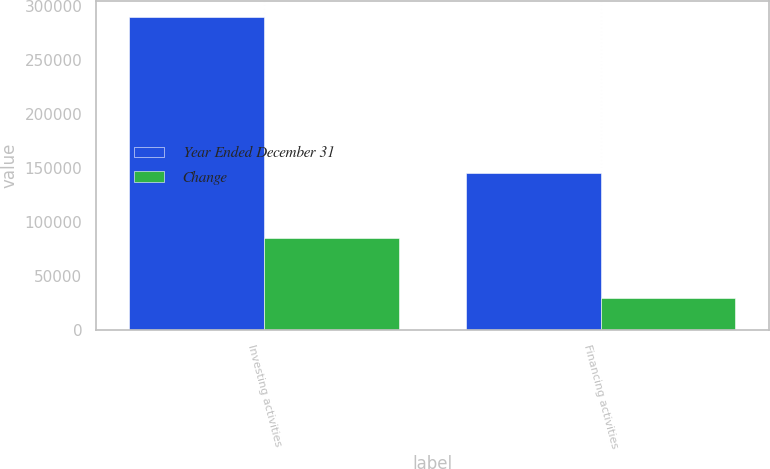Convert chart. <chart><loc_0><loc_0><loc_500><loc_500><stacked_bar_chart><ecel><fcel>Investing activities<fcel>Financing activities<nl><fcel>Year Ended December 31<fcel>290346<fcel>145665<nl><fcel>Change<fcel>85295<fcel>30123<nl></chart> 